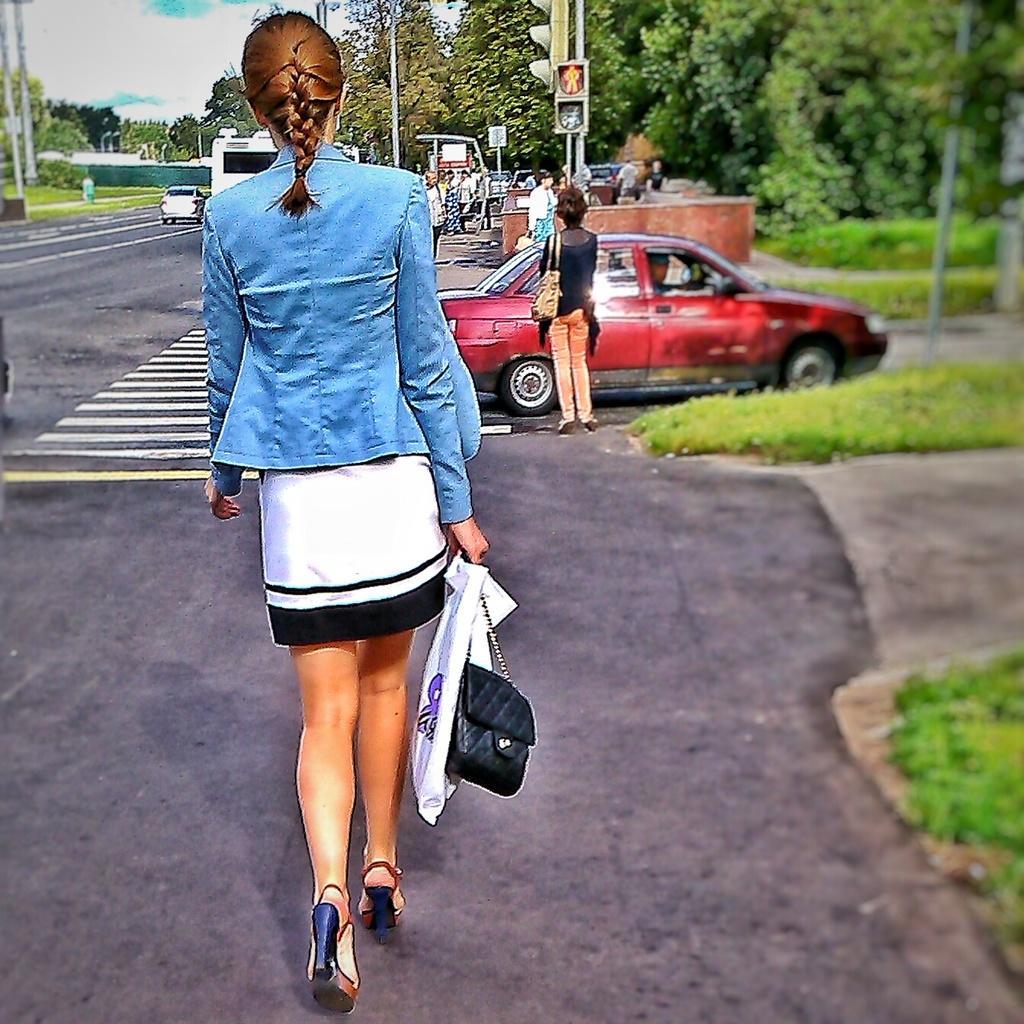Please provide a concise description of this image. A woman is walking on the road, in the middle a car is moving on this road which is in dark red color and there is a signal. In the right side there are trees. 